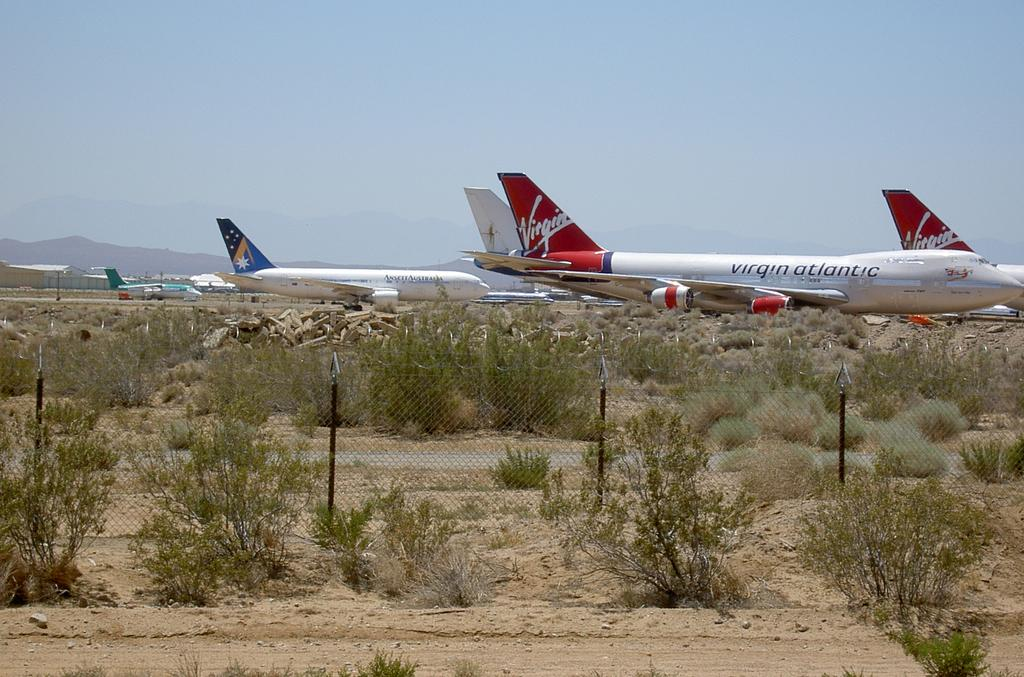<image>
Present a compact description of the photo's key features. Two Virgin planes as well as ansett Australia and others sit outside at a desert airport. 